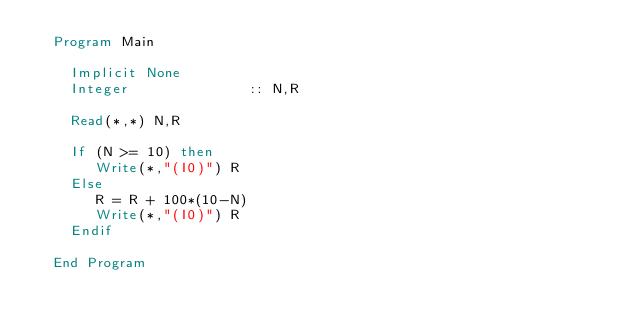Convert code to text. <code><loc_0><loc_0><loc_500><loc_500><_FORTRAN_>  Program Main

    Implicit None
    Integer              :: N,R

    Read(*,*) N,R

    If (N >= 10) then
       Write(*,"(I0)") R
    Else
       R = R + 100*(10-N)
       Write(*,"(I0)") R
    Endif

  End Program
</code> 